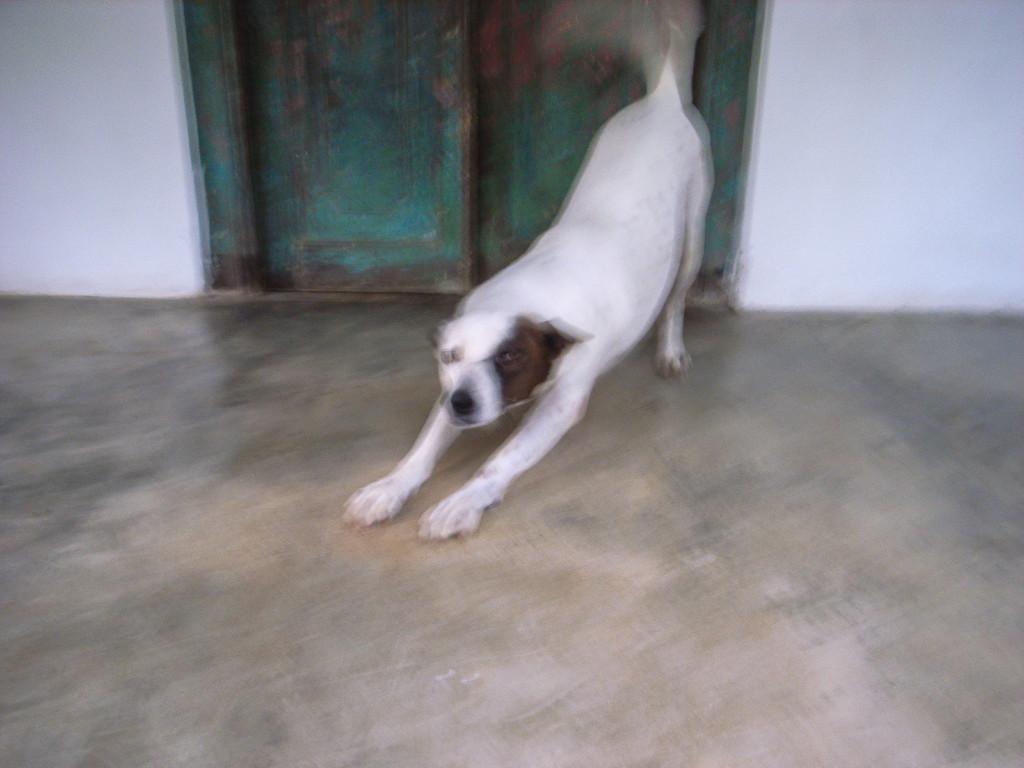Describe this image in one or two sentences. In this image in the center there is a dog, and at the bottom there is floor. In the background there is wall and doors. 